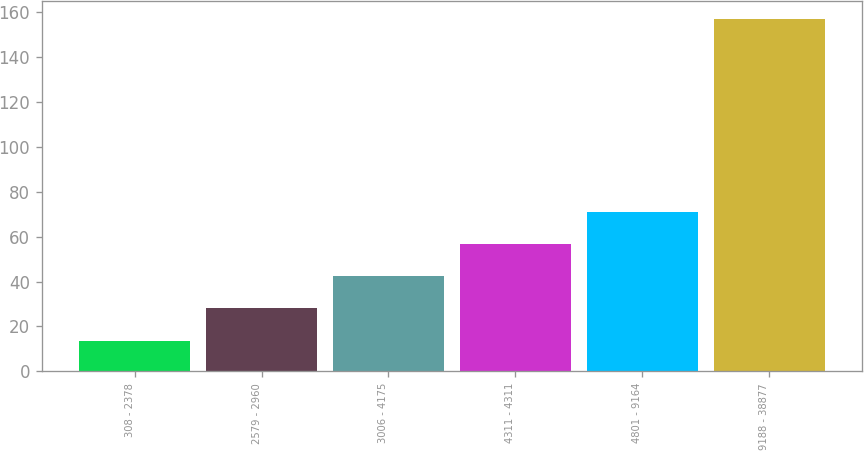<chart> <loc_0><loc_0><loc_500><loc_500><bar_chart><fcel>308 - 2378<fcel>2579 - 2960<fcel>3006 - 4175<fcel>4311 - 4311<fcel>4801 - 9164<fcel>9188 - 38877<nl><fcel>13.41<fcel>28.03<fcel>42.38<fcel>56.73<fcel>71.08<fcel>156.9<nl></chart> 